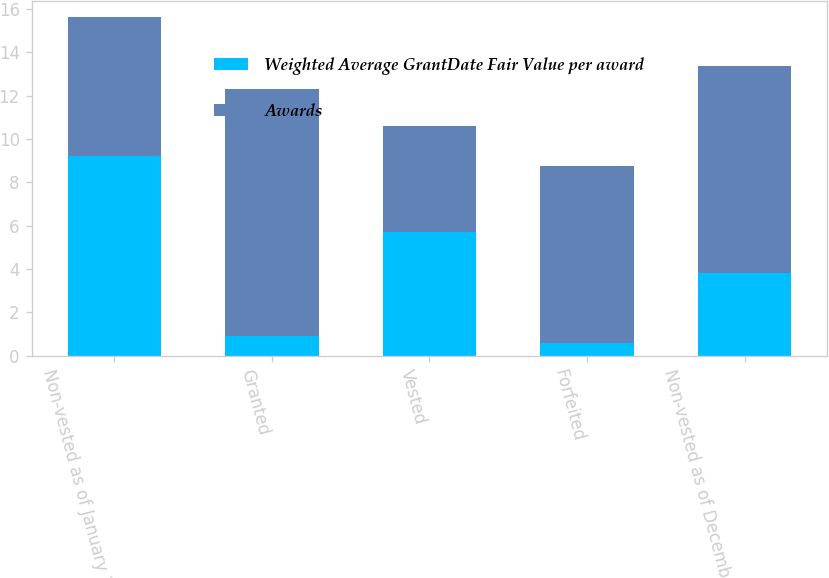<chart> <loc_0><loc_0><loc_500><loc_500><stacked_bar_chart><ecel><fcel>Non-vested as of January 1<fcel>Granted<fcel>Vested<fcel>Forfeited<fcel>Non-vested as of December 31<nl><fcel>Weighted Average GrantDate Fair Value per award<fcel>9.2<fcel>0.9<fcel>5.7<fcel>0.6<fcel>3.8<nl><fcel>Awards<fcel>6.41<fcel>11.43<fcel>4.88<fcel>8.16<fcel>9.55<nl></chart> 